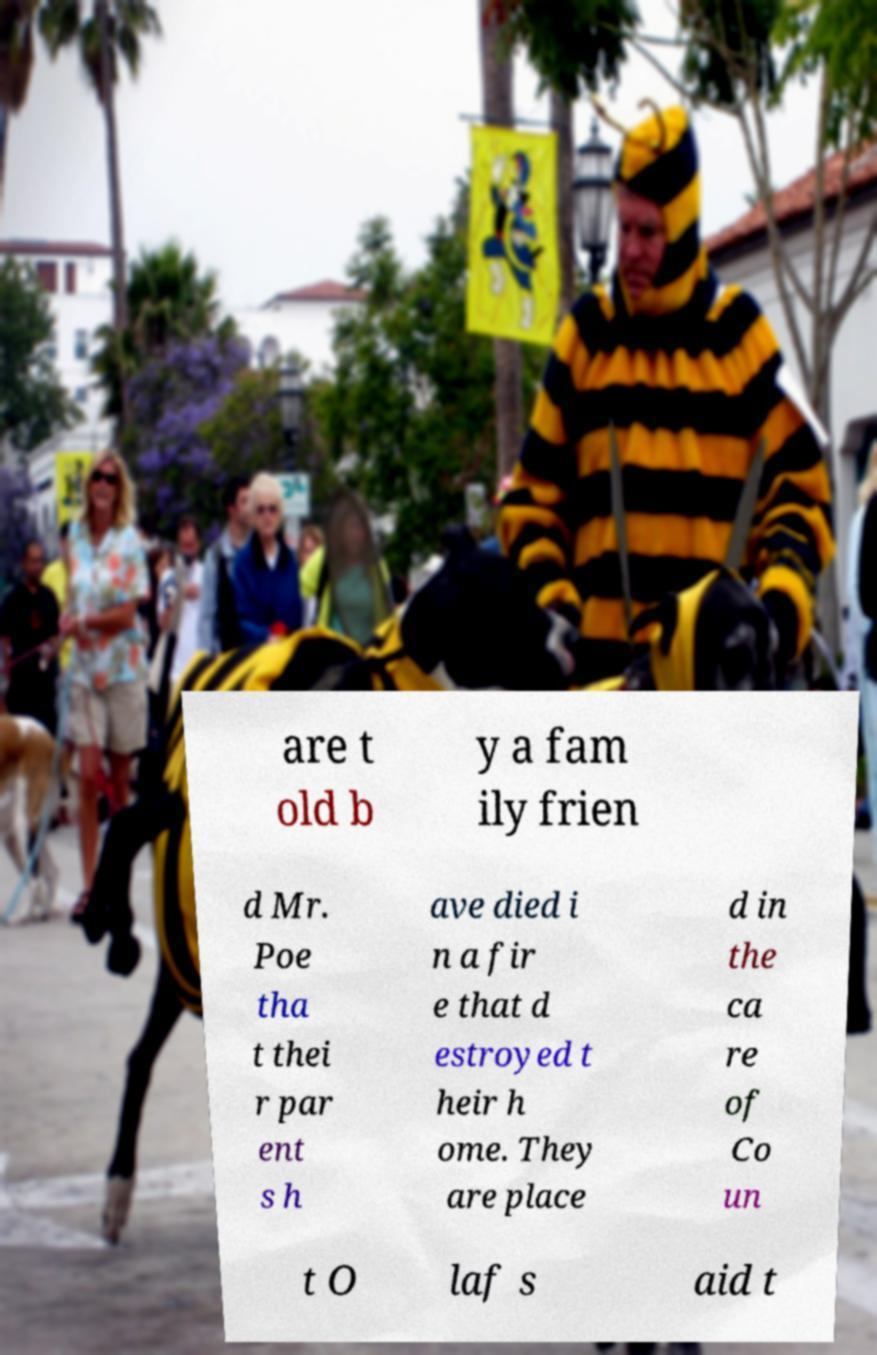There's text embedded in this image that I need extracted. Can you transcribe it verbatim? are t old b y a fam ily frien d Mr. Poe tha t thei r par ent s h ave died i n a fir e that d estroyed t heir h ome. They are place d in the ca re of Co un t O laf s aid t 